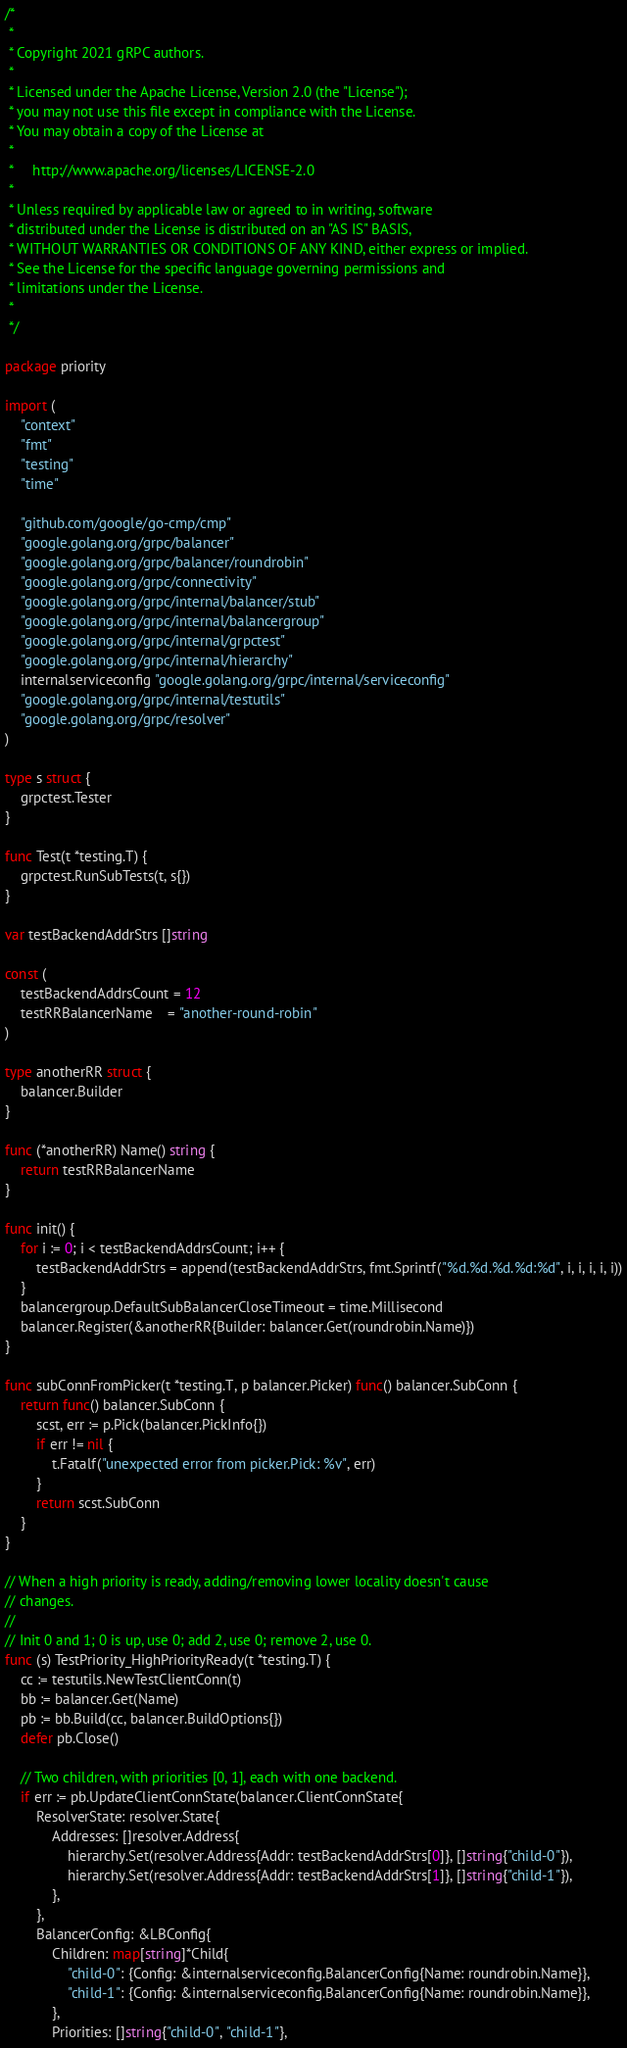<code> <loc_0><loc_0><loc_500><loc_500><_Go_>/*
 *
 * Copyright 2021 gRPC authors.
 *
 * Licensed under the Apache License, Version 2.0 (the "License");
 * you may not use this file except in compliance with the License.
 * You may obtain a copy of the License at
 *
 *     http://www.apache.org/licenses/LICENSE-2.0
 *
 * Unless required by applicable law or agreed to in writing, software
 * distributed under the License is distributed on an "AS IS" BASIS,
 * WITHOUT WARRANTIES OR CONDITIONS OF ANY KIND, either express or implied.
 * See the License for the specific language governing permissions and
 * limitations under the License.
 *
 */

package priority

import (
	"context"
	"fmt"
	"testing"
	"time"

	"github.com/google/go-cmp/cmp"
	"google.golang.org/grpc/balancer"
	"google.golang.org/grpc/balancer/roundrobin"
	"google.golang.org/grpc/connectivity"
	"google.golang.org/grpc/internal/balancer/stub"
	"google.golang.org/grpc/internal/balancergroup"
	"google.golang.org/grpc/internal/grpctest"
	"google.golang.org/grpc/internal/hierarchy"
	internalserviceconfig "google.golang.org/grpc/internal/serviceconfig"
	"google.golang.org/grpc/internal/testutils"
	"google.golang.org/grpc/resolver"
)

type s struct {
	grpctest.Tester
}

func Test(t *testing.T) {
	grpctest.RunSubTests(t, s{})
}

var testBackendAddrStrs []string

const (
	testBackendAddrsCount = 12
	testRRBalancerName    = "another-round-robin"
)

type anotherRR struct {
	balancer.Builder
}

func (*anotherRR) Name() string {
	return testRRBalancerName
}

func init() {
	for i := 0; i < testBackendAddrsCount; i++ {
		testBackendAddrStrs = append(testBackendAddrStrs, fmt.Sprintf("%d.%d.%d.%d:%d", i, i, i, i, i))
	}
	balancergroup.DefaultSubBalancerCloseTimeout = time.Millisecond
	balancer.Register(&anotherRR{Builder: balancer.Get(roundrobin.Name)})
}

func subConnFromPicker(t *testing.T, p balancer.Picker) func() balancer.SubConn {
	return func() balancer.SubConn {
		scst, err := p.Pick(balancer.PickInfo{})
		if err != nil {
			t.Fatalf("unexpected error from picker.Pick: %v", err)
		}
		return scst.SubConn
	}
}

// When a high priority is ready, adding/removing lower locality doesn't cause
// changes.
//
// Init 0 and 1; 0 is up, use 0; add 2, use 0; remove 2, use 0.
func (s) TestPriority_HighPriorityReady(t *testing.T) {
	cc := testutils.NewTestClientConn(t)
	bb := balancer.Get(Name)
	pb := bb.Build(cc, balancer.BuildOptions{})
	defer pb.Close()

	// Two children, with priorities [0, 1], each with one backend.
	if err := pb.UpdateClientConnState(balancer.ClientConnState{
		ResolverState: resolver.State{
			Addresses: []resolver.Address{
				hierarchy.Set(resolver.Address{Addr: testBackendAddrStrs[0]}, []string{"child-0"}),
				hierarchy.Set(resolver.Address{Addr: testBackendAddrStrs[1]}, []string{"child-1"}),
			},
		},
		BalancerConfig: &LBConfig{
			Children: map[string]*Child{
				"child-0": {Config: &internalserviceconfig.BalancerConfig{Name: roundrobin.Name}},
				"child-1": {Config: &internalserviceconfig.BalancerConfig{Name: roundrobin.Name}},
			},
			Priorities: []string{"child-0", "child-1"},</code> 